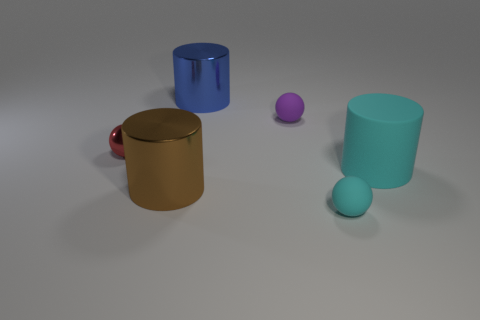Subtract 1 balls. How many balls are left? 2 Add 2 tiny red things. How many objects exist? 8 Add 1 big blue metal cylinders. How many big blue metal cylinders exist? 2 Subtract 0 red cylinders. How many objects are left? 6 Subtract all big gray matte things. Subtract all tiny cyan balls. How many objects are left? 5 Add 1 cylinders. How many cylinders are left? 4 